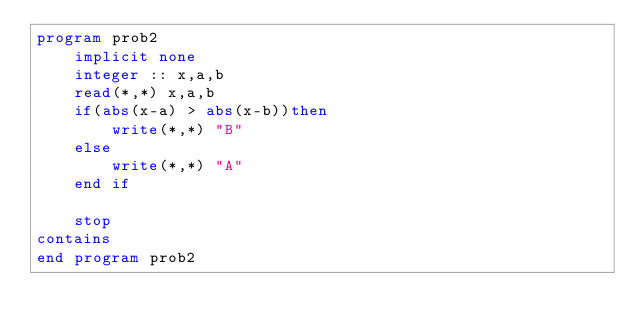<code> <loc_0><loc_0><loc_500><loc_500><_FORTRAN_>program prob2
    implicit none
    integer :: x,a,b
    read(*,*) x,a,b
    if(abs(x-a) > abs(x-b))then
        write(*,*) "B"
    else
        write(*,*) "A"
    end if

    stop
contains
end program prob2</code> 